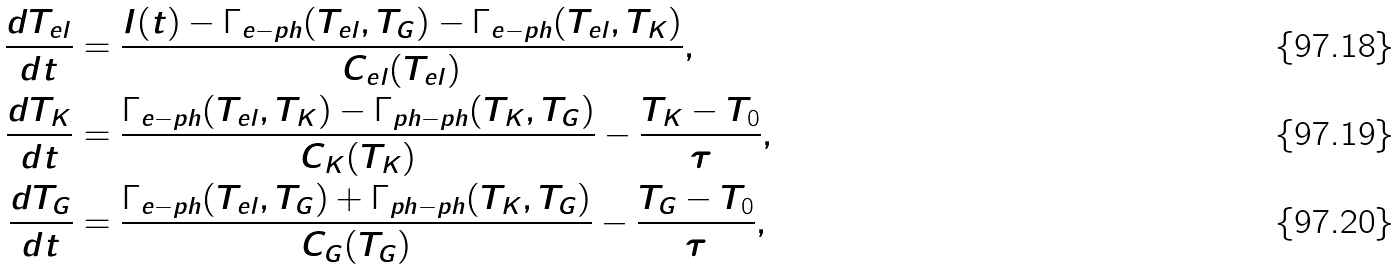Convert formula to latex. <formula><loc_0><loc_0><loc_500><loc_500>\frac { d T _ { e l } } { d t } & = \frac { I ( t ) - \Gamma _ { e - p h } ( T _ { e l } , T _ { G } ) - \Gamma _ { e - p h } ( T _ { e l } , T _ { K } ) } { C _ { e l } ( T _ { e l } ) } , \\ \frac { d T _ { K } } { d t } & = \frac { \Gamma _ { e - p h } ( T _ { e l } , T _ { K } ) - \Gamma _ { p h - p h } ( T _ { K } , T _ { G } ) } { C _ { K } ( T _ { K } ) } - \frac { T _ { K } - T _ { 0 } } { \tau } , \\ \frac { d T _ { G } } { d t } & = \frac { \Gamma _ { e - p h } ( T _ { e l } , T _ { G } ) + \Gamma _ { p h - p h } ( T _ { K } , T _ { G } ) } { C _ { G } ( T _ { G } ) } - \frac { T _ { G } - T _ { 0 } } { \tau } ,</formula> 